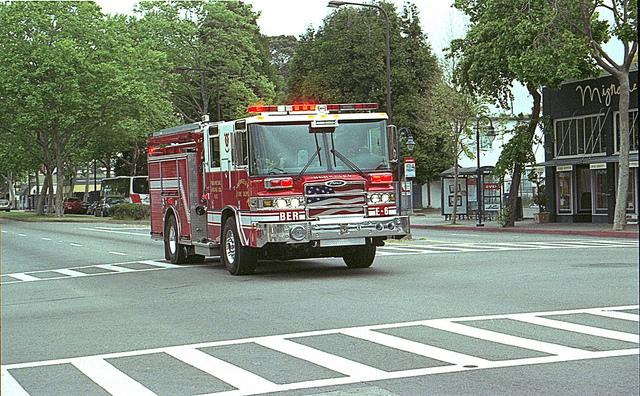What do the flashing lights indicate on this vehicle? emergency 